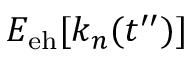Convert formula to latex. <formula><loc_0><loc_0><loc_500><loc_500>E _ { e h } [ k _ { n } ( t ^ { \prime \prime } ) ]</formula> 